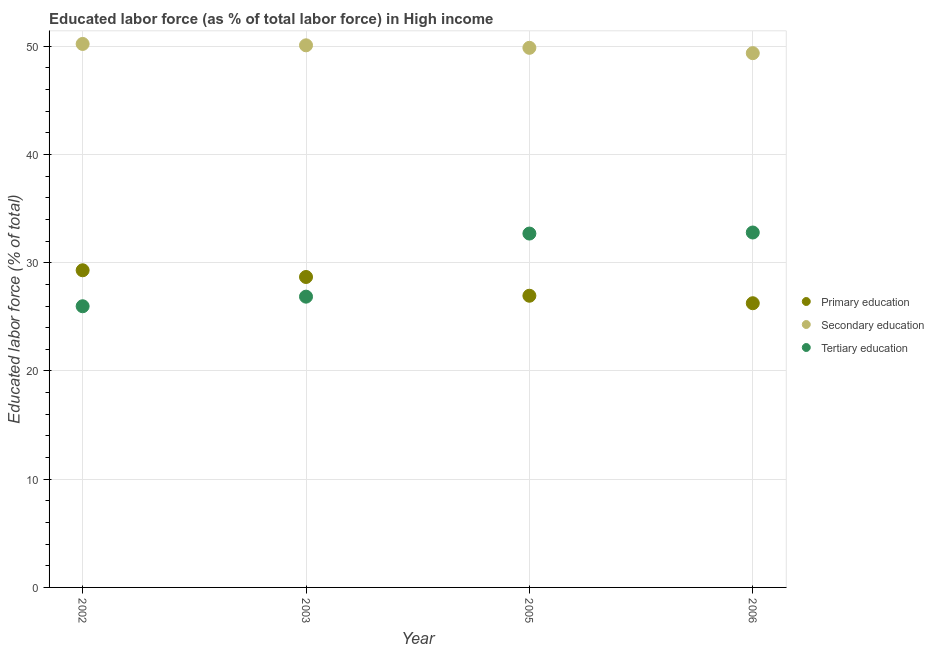How many different coloured dotlines are there?
Your response must be concise. 3. Is the number of dotlines equal to the number of legend labels?
Keep it short and to the point. Yes. What is the percentage of labor force who received secondary education in 2006?
Make the answer very short. 49.36. Across all years, what is the maximum percentage of labor force who received secondary education?
Ensure brevity in your answer.  50.21. Across all years, what is the minimum percentage of labor force who received secondary education?
Your response must be concise. 49.36. What is the total percentage of labor force who received secondary education in the graph?
Ensure brevity in your answer.  199.51. What is the difference between the percentage of labor force who received primary education in 2002 and that in 2003?
Offer a very short reply. 0.62. What is the difference between the percentage of labor force who received secondary education in 2003 and the percentage of labor force who received primary education in 2002?
Your answer should be very brief. 20.78. What is the average percentage of labor force who received tertiary education per year?
Your response must be concise. 29.58. In the year 2003, what is the difference between the percentage of labor force who received primary education and percentage of labor force who received tertiary education?
Your response must be concise. 1.82. In how many years, is the percentage of labor force who received primary education greater than 44 %?
Make the answer very short. 0. What is the ratio of the percentage of labor force who received secondary education in 2005 to that in 2006?
Keep it short and to the point. 1.01. Is the percentage of labor force who received primary education in 2002 less than that in 2006?
Keep it short and to the point. No. What is the difference between the highest and the second highest percentage of labor force who received tertiary education?
Make the answer very short. 0.1. What is the difference between the highest and the lowest percentage of labor force who received primary education?
Make the answer very short. 3.04. Is the sum of the percentage of labor force who received secondary education in 2003 and 2005 greater than the maximum percentage of labor force who received primary education across all years?
Offer a terse response. Yes. Does the percentage of labor force who received primary education monotonically increase over the years?
Offer a very short reply. No. Is the percentage of labor force who received secondary education strictly greater than the percentage of labor force who received primary education over the years?
Your answer should be compact. Yes. Does the graph contain any zero values?
Provide a short and direct response. No. What is the title of the graph?
Offer a very short reply. Educated labor force (as % of total labor force) in High income. Does "Nuclear sources" appear as one of the legend labels in the graph?
Offer a very short reply. No. What is the label or title of the Y-axis?
Your answer should be very brief. Educated labor force (% of total). What is the Educated labor force (% of total) in Primary education in 2002?
Provide a short and direct response. 29.3. What is the Educated labor force (% of total) of Secondary education in 2002?
Give a very brief answer. 50.21. What is the Educated labor force (% of total) of Tertiary education in 2002?
Offer a terse response. 25.98. What is the Educated labor force (% of total) in Primary education in 2003?
Give a very brief answer. 28.68. What is the Educated labor force (% of total) of Secondary education in 2003?
Give a very brief answer. 50.08. What is the Educated labor force (% of total) of Tertiary education in 2003?
Offer a very short reply. 26.86. What is the Educated labor force (% of total) of Primary education in 2005?
Provide a short and direct response. 26.95. What is the Educated labor force (% of total) in Secondary education in 2005?
Ensure brevity in your answer.  49.85. What is the Educated labor force (% of total) of Tertiary education in 2005?
Your response must be concise. 32.69. What is the Educated labor force (% of total) of Primary education in 2006?
Make the answer very short. 26.26. What is the Educated labor force (% of total) of Secondary education in 2006?
Your answer should be very brief. 49.36. What is the Educated labor force (% of total) in Tertiary education in 2006?
Offer a terse response. 32.79. Across all years, what is the maximum Educated labor force (% of total) in Primary education?
Your answer should be compact. 29.3. Across all years, what is the maximum Educated labor force (% of total) in Secondary education?
Make the answer very short. 50.21. Across all years, what is the maximum Educated labor force (% of total) of Tertiary education?
Offer a very short reply. 32.79. Across all years, what is the minimum Educated labor force (% of total) in Primary education?
Give a very brief answer. 26.26. Across all years, what is the minimum Educated labor force (% of total) in Secondary education?
Provide a short and direct response. 49.36. Across all years, what is the minimum Educated labor force (% of total) in Tertiary education?
Make the answer very short. 25.98. What is the total Educated labor force (% of total) of Primary education in the graph?
Ensure brevity in your answer.  111.19. What is the total Educated labor force (% of total) in Secondary education in the graph?
Provide a succinct answer. 199.51. What is the total Educated labor force (% of total) in Tertiary education in the graph?
Your answer should be compact. 118.32. What is the difference between the Educated labor force (% of total) of Primary education in 2002 and that in 2003?
Give a very brief answer. 0.62. What is the difference between the Educated labor force (% of total) of Secondary education in 2002 and that in 2003?
Keep it short and to the point. 0.13. What is the difference between the Educated labor force (% of total) of Tertiary education in 2002 and that in 2003?
Give a very brief answer. -0.89. What is the difference between the Educated labor force (% of total) of Primary education in 2002 and that in 2005?
Provide a short and direct response. 2.35. What is the difference between the Educated labor force (% of total) in Secondary education in 2002 and that in 2005?
Provide a short and direct response. 0.36. What is the difference between the Educated labor force (% of total) in Tertiary education in 2002 and that in 2005?
Give a very brief answer. -6.72. What is the difference between the Educated labor force (% of total) of Primary education in 2002 and that in 2006?
Ensure brevity in your answer.  3.04. What is the difference between the Educated labor force (% of total) of Secondary education in 2002 and that in 2006?
Your response must be concise. 0.85. What is the difference between the Educated labor force (% of total) in Tertiary education in 2002 and that in 2006?
Your response must be concise. -6.81. What is the difference between the Educated labor force (% of total) of Primary education in 2003 and that in 2005?
Ensure brevity in your answer.  1.73. What is the difference between the Educated labor force (% of total) of Secondary education in 2003 and that in 2005?
Your answer should be very brief. 0.23. What is the difference between the Educated labor force (% of total) in Tertiary education in 2003 and that in 2005?
Provide a succinct answer. -5.83. What is the difference between the Educated labor force (% of total) in Primary education in 2003 and that in 2006?
Keep it short and to the point. 2.42. What is the difference between the Educated labor force (% of total) in Secondary education in 2003 and that in 2006?
Offer a very short reply. 0.72. What is the difference between the Educated labor force (% of total) of Tertiary education in 2003 and that in 2006?
Give a very brief answer. -5.93. What is the difference between the Educated labor force (% of total) of Primary education in 2005 and that in 2006?
Make the answer very short. 0.69. What is the difference between the Educated labor force (% of total) of Secondary education in 2005 and that in 2006?
Provide a succinct answer. 0.49. What is the difference between the Educated labor force (% of total) in Tertiary education in 2005 and that in 2006?
Offer a very short reply. -0.1. What is the difference between the Educated labor force (% of total) of Primary education in 2002 and the Educated labor force (% of total) of Secondary education in 2003?
Offer a very short reply. -20.78. What is the difference between the Educated labor force (% of total) of Primary education in 2002 and the Educated labor force (% of total) of Tertiary education in 2003?
Your answer should be very brief. 2.44. What is the difference between the Educated labor force (% of total) in Secondary education in 2002 and the Educated labor force (% of total) in Tertiary education in 2003?
Ensure brevity in your answer.  23.35. What is the difference between the Educated labor force (% of total) of Primary education in 2002 and the Educated labor force (% of total) of Secondary education in 2005?
Your answer should be very brief. -20.55. What is the difference between the Educated labor force (% of total) of Primary education in 2002 and the Educated labor force (% of total) of Tertiary education in 2005?
Provide a succinct answer. -3.39. What is the difference between the Educated labor force (% of total) in Secondary education in 2002 and the Educated labor force (% of total) in Tertiary education in 2005?
Make the answer very short. 17.52. What is the difference between the Educated labor force (% of total) in Primary education in 2002 and the Educated labor force (% of total) in Secondary education in 2006?
Give a very brief answer. -20.06. What is the difference between the Educated labor force (% of total) in Primary education in 2002 and the Educated labor force (% of total) in Tertiary education in 2006?
Offer a terse response. -3.49. What is the difference between the Educated labor force (% of total) of Secondary education in 2002 and the Educated labor force (% of total) of Tertiary education in 2006?
Your response must be concise. 17.42. What is the difference between the Educated labor force (% of total) in Primary education in 2003 and the Educated labor force (% of total) in Secondary education in 2005?
Ensure brevity in your answer.  -21.17. What is the difference between the Educated labor force (% of total) of Primary education in 2003 and the Educated labor force (% of total) of Tertiary education in 2005?
Keep it short and to the point. -4.01. What is the difference between the Educated labor force (% of total) of Secondary education in 2003 and the Educated labor force (% of total) of Tertiary education in 2005?
Your answer should be very brief. 17.39. What is the difference between the Educated labor force (% of total) of Primary education in 2003 and the Educated labor force (% of total) of Secondary education in 2006?
Your response must be concise. -20.68. What is the difference between the Educated labor force (% of total) of Primary education in 2003 and the Educated labor force (% of total) of Tertiary education in 2006?
Provide a short and direct response. -4.11. What is the difference between the Educated labor force (% of total) in Secondary education in 2003 and the Educated labor force (% of total) in Tertiary education in 2006?
Offer a very short reply. 17.29. What is the difference between the Educated labor force (% of total) in Primary education in 2005 and the Educated labor force (% of total) in Secondary education in 2006?
Offer a terse response. -22.41. What is the difference between the Educated labor force (% of total) in Primary education in 2005 and the Educated labor force (% of total) in Tertiary education in 2006?
Keep it short and to the point. -5.84. What is the difference between the Educated labor force (% of total) of Secondary education in 2005 and the Educated labor force (% of total) of Tertiary education in 2006?
Your response must be concise. 17.06. What is the average Educated labor force (% of total) of Primary education per year?
Offer a terse response. 27.8. What is the average Educated labor force (% of total) in Secondary education per year?
Your answer should be compact. 49.88. What is the average Educated labor force (% of total) in Tertiary education per year?
Make the answer very short. 29.58. In the year 2002, what is the difference between the Educated labor force (% of total) of Primary education and Educated labor force (% of total) of Secondary education?
Your response must be concise. -20.91. In the year 2002, what is the difference between the Educated labor force (% of total) in Primary education and Educated labor force (% of total) in Tertiary education?
Keep it short and to the point. 3.32. In the year 2002, what is the difference between the Educated labor force (% of total) of Secondary education and Educated labor force (% of total) of Tertiary education?
Your answer should be compact. 24.23. In the year 2003, what is the difference between the Educated labor force (% of total) in Primary education and Educated labor force (% of total) in Secondary education?
Keep it short and to the point. -21.4. In the year 2003, what is the difference between the Educated labor force (% of total) of Primary education and Educated labor force (% of total) of Tertiary education?
Offer a terse response. 1.82. In the year 2003, what is the difference between the Educated labor force (% of total) of Secondary education and Educated labor force (% of total) of Tertiary education?
Provide a succinct answer. 23.22. In the year 2005, what is the difference between the Educated labor force (% of total) in Primary education and Educated labor force (% of total) in Secondary education?
Provide a short and direct response. -22.91. In the year 2005, what is the difference between the Educated labor force (% of total) of Primary education and Educated labor force (% of total) of Tertiary education?
Ensure brevity in your answer.  -5.75. In the year 2005, what is the difference between the Educated labor force (% of total) in Secondary education and Educated labor force (% of total) in Tertiary education?
Ensure brevity in your answer.  17.16. In the year 2006, what is the difference between the Educated labor force (% of total) of Primary education and Educated labor force (% of total) of Secondary education?
Your answer should be very brief. -23.1. In the year 2006, what is the difference between the Educated labor force (% of total) of Primary education and Educated labor force (% of total) of Tertiary education?
Provide a succinct answer. -6.53. In the year 2006, what is the difference between the Educated labor force (% of total) of Secondary education and Educated labor force (% of total) of Tertiary education?
Your answer should be very brief. 16.57. What is the ratio of the Educated labor force (% of total) in Primary education in 2002 to that in 2003?
Give a very brief answer. 1.02. What is the ratio of the Educated labor force (% of total) of Tertiary education in 2002 to that in 2003?
Your answer should be very brief. 0.97. What is the ratio of the Educated labor force (% of total) in Primary education in 2002 to that in 2005?
Give a very brief answer. 1.09. What is the ratio of the Educated labor force (% of total) of Secondary education in 2002 to that in 2005?
Your answer should be very brief. 1.01. What is the ratio of the Educated labor force (% of total) of Tertiary education in 2002 to that in 2005?
Offer a very short reply. 0.79. What is the ratio of the Educated labor force (% of total) of Primary education in 2002 to that in 2006?
Provide a short and direct response. 1.12. What is the ratio of the Educated labor force (% of total) in Secondary education in 2002 to that in 2006?
Offer a very short reply. 1.02. What is the ratio of the Educated labor force (% of total) in Tertiary education in 2002 to that in 2006?
Make the answer very short. 0.79. What is the ratio of the Educated labor force (% of total) of Primary education in 2003 to that in 2005?
Offer a terse response. 1.06. What is the ratio of the Educated labor force (% of total) of Secondary education in 2003 to that in 2005?
Offer a terse response. 1. What is the ratio of the Educated labor force (% of total) in Tertiary education in 2003 to that in 2005?
Your answer should be compact. 0.82. What is the ratio of the Educated labor force (% of total) of Primary education in 2003 to that in 2006?
Your response must be concise. 1.09. What is the ratio of the Educated labor force (% of total) in Secondary education in 2003 to that in 2006?
Give a very brief answer. 1.01. What is the ratio of the Educated labor force (% of total) in Tertiary education in 2003 to that in 2006?
Your answer should be compact. 0.82. What is the ratio of the Educated labor force (% of total) of Primary education in 2005 to that in 2006?
Offer a terse response. 1.03. What is the difference between the highest and the second highest Educated labor force (% of total) of Primary education?
Your answer should be compact. 0.62. What is the difference between the highest and the second highest Educated labor force (% of total) in Secondary education?
Make the answer very short. 0.13. What is the difference between the highest and the second highest Educated labor force (% of total) of Tertiary education?
Provide a short and direct response. 0.1. What is the difference between the highest and the lowest Educated labor force (% of total) in Primary education?
Your response must be concise. 3.04. What is the difference between the highest and the lowest Educated labor force (% of total) of Secondary education?
Keep it short and to the point. 0.85. What is the difference between the highest and the lowest Educated labor force (% of total) of Tertiary education?
Provide a short and direct response. 6.81. 